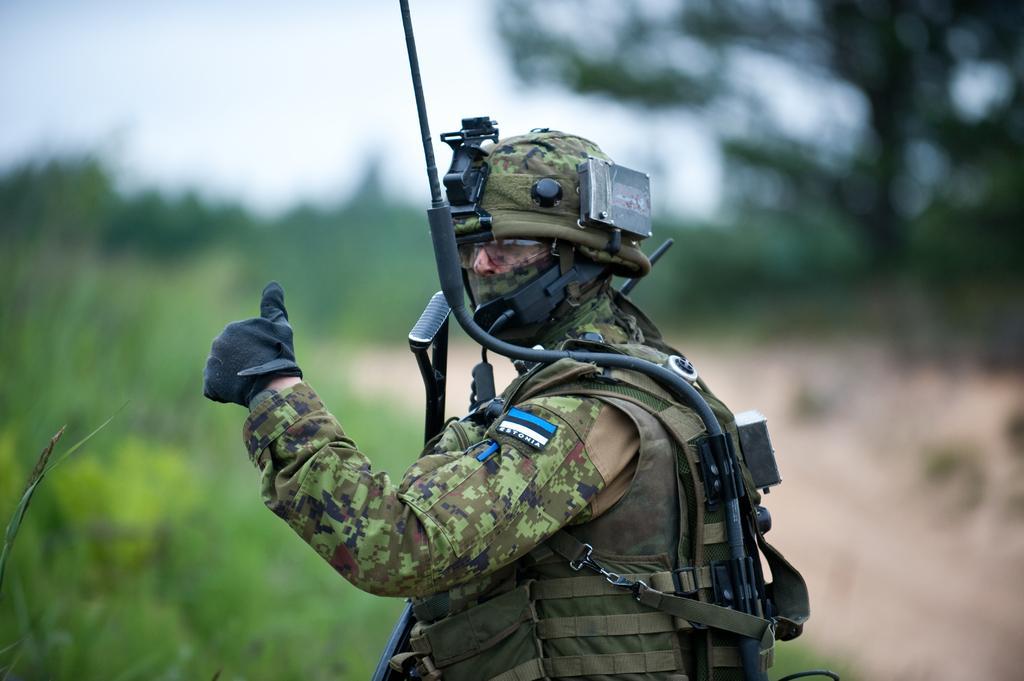How would you summarize this image in a sentence or two? Here in this picture we can see a person in military dress and we can see gloves, gun, goggles and helmet and jacket present on him over there and we can see a rope to his back over there and in the front we can see plants and trees present all over there. 